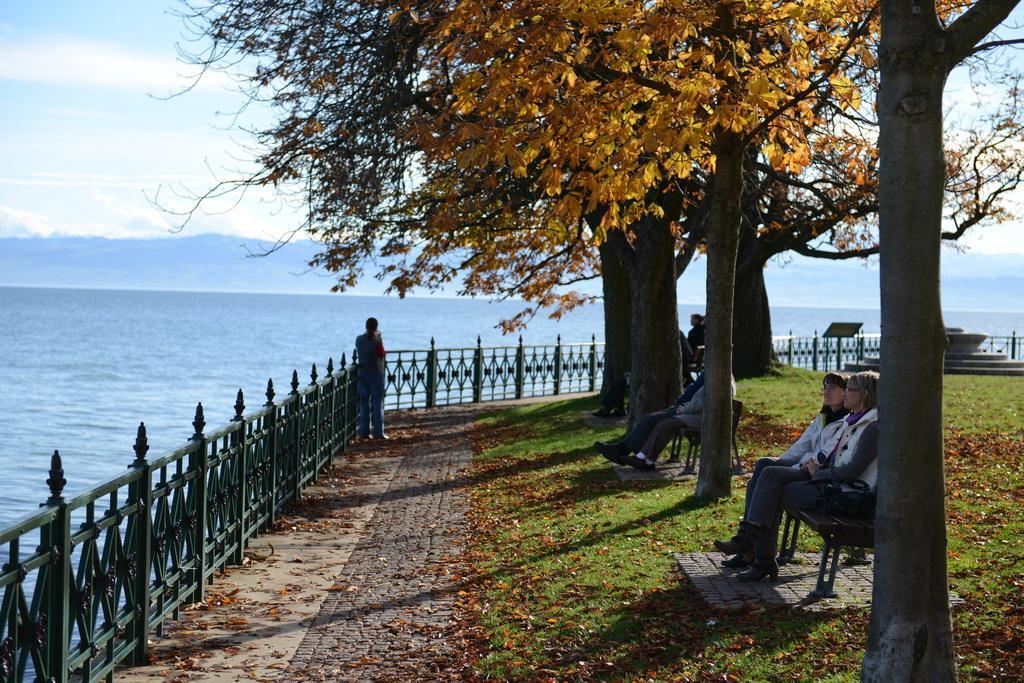Describe this image in one or two sentences. In this image there are group of persons sitting in bench in the garden at the back ground there are mountains, beach ,iron grills, tree, grass, sky. 